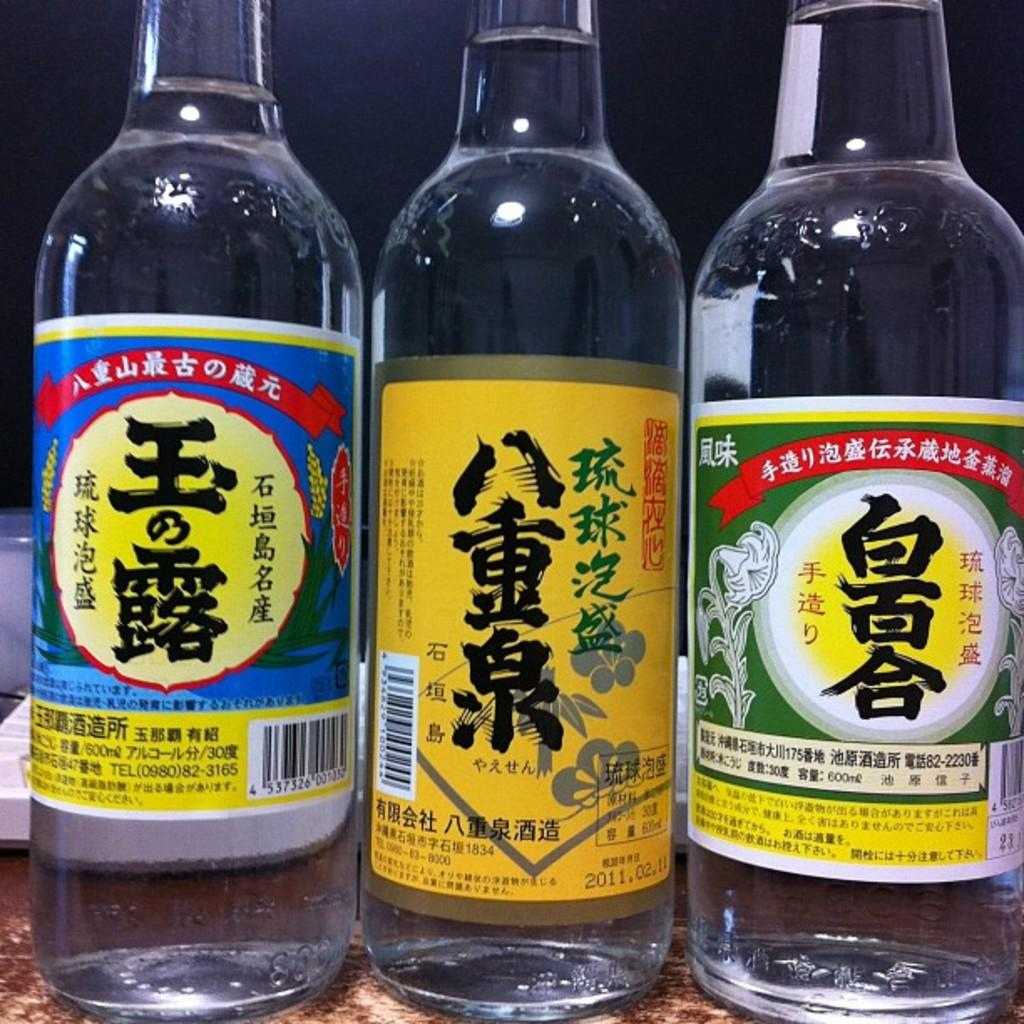How many water bottles are visible in the image? There are three water bottles in the image. Are there any toys or a farm visible in the image? No, there are no toys or farm present in the image; it only features three water bottles. Is there any oatmeal visible in the image? No, there is no oatmeal present in the image. 